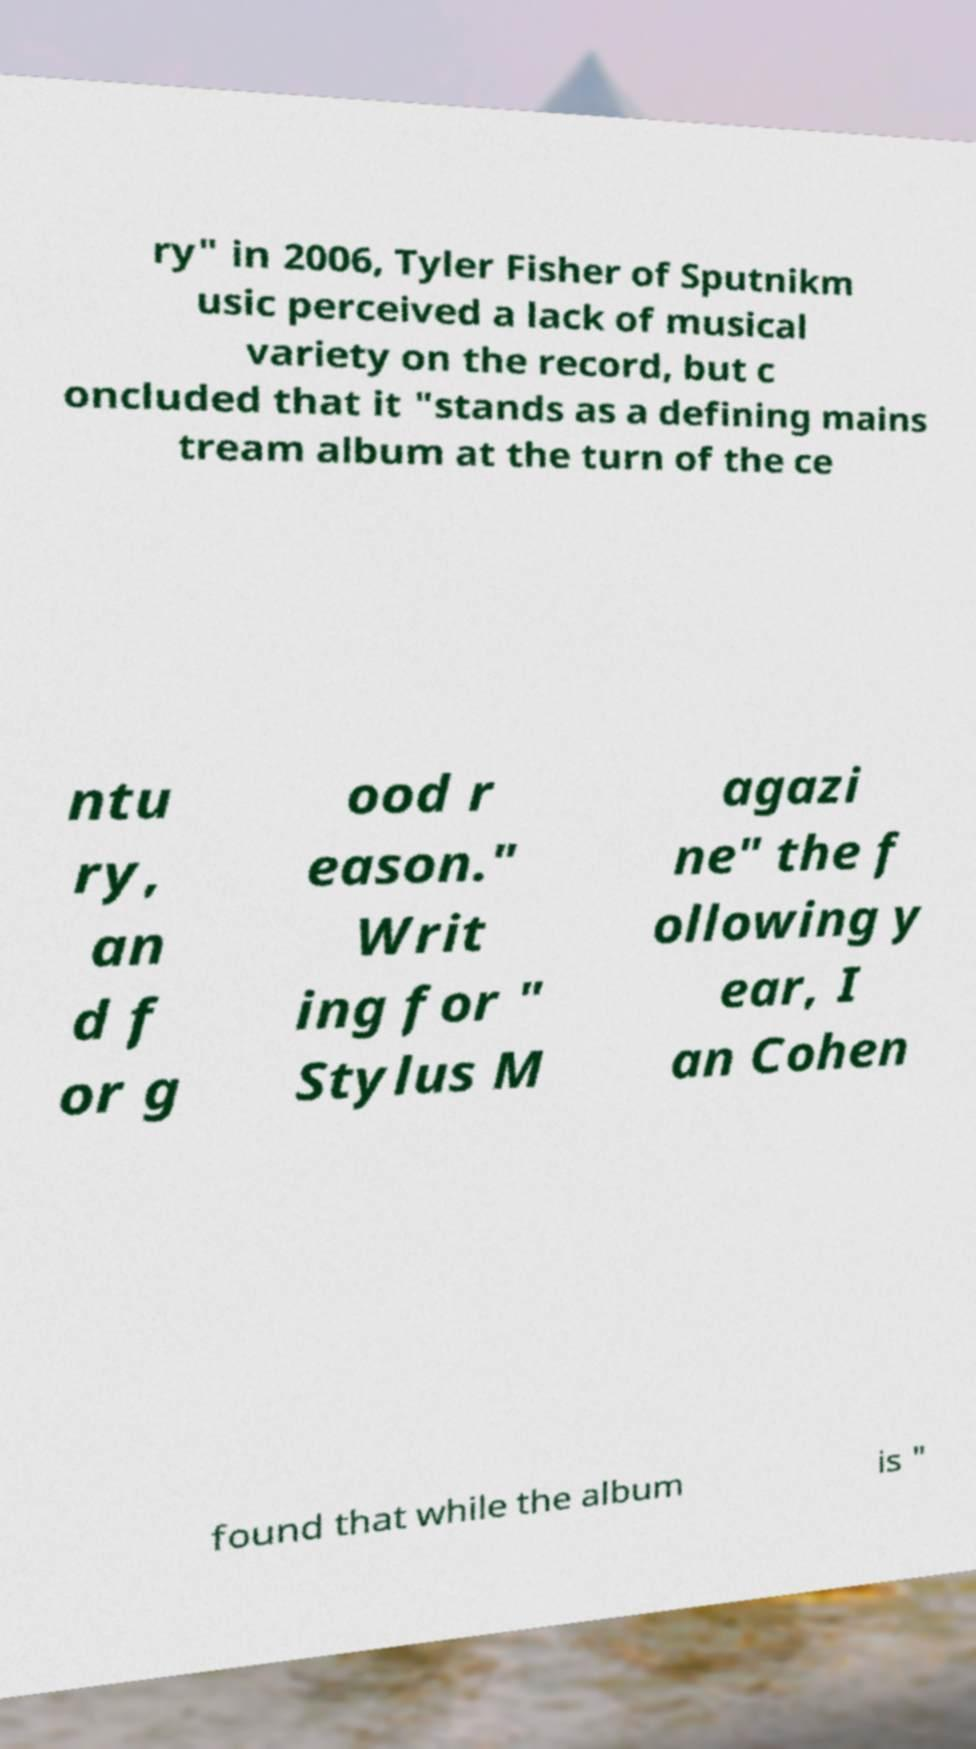Could you extract and type out the text from this image? ry" in 2006, Tyler Fisher of Sputnikm usic perceived a lack of musical variety on the record, but c oncluded that it "stands as a defining mains tream album at the turn of the ce ntu ry, an d f or g ood r eason." Writ ing for " Stylus M agazi ne" the f ollowing y ear, I an Cohen found that while the album is " 